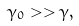Convert formula to latex. <formula><loc_0><loc_0><loc_500><loc_500>\gamma _ { 0 } > > \gamma ,</formula> 